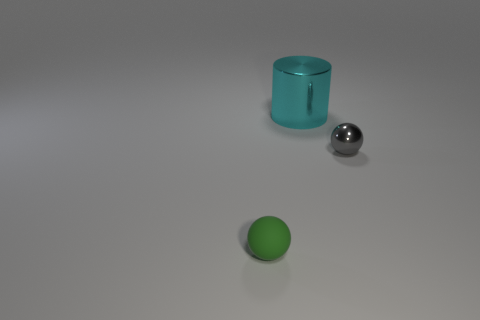Could you describe the lighting in the scene? The scene is lit by a diffuse, overhead light source that casts soft shadows beneath each object, suggesting an indoor setting with ambient light that could be from either natural or artificial sources. The subtle highlights on the objects, especially the shiny cyan cylinder and the metallic sphere, also hint at the presence of a strong yet not harsh light in the environment. 